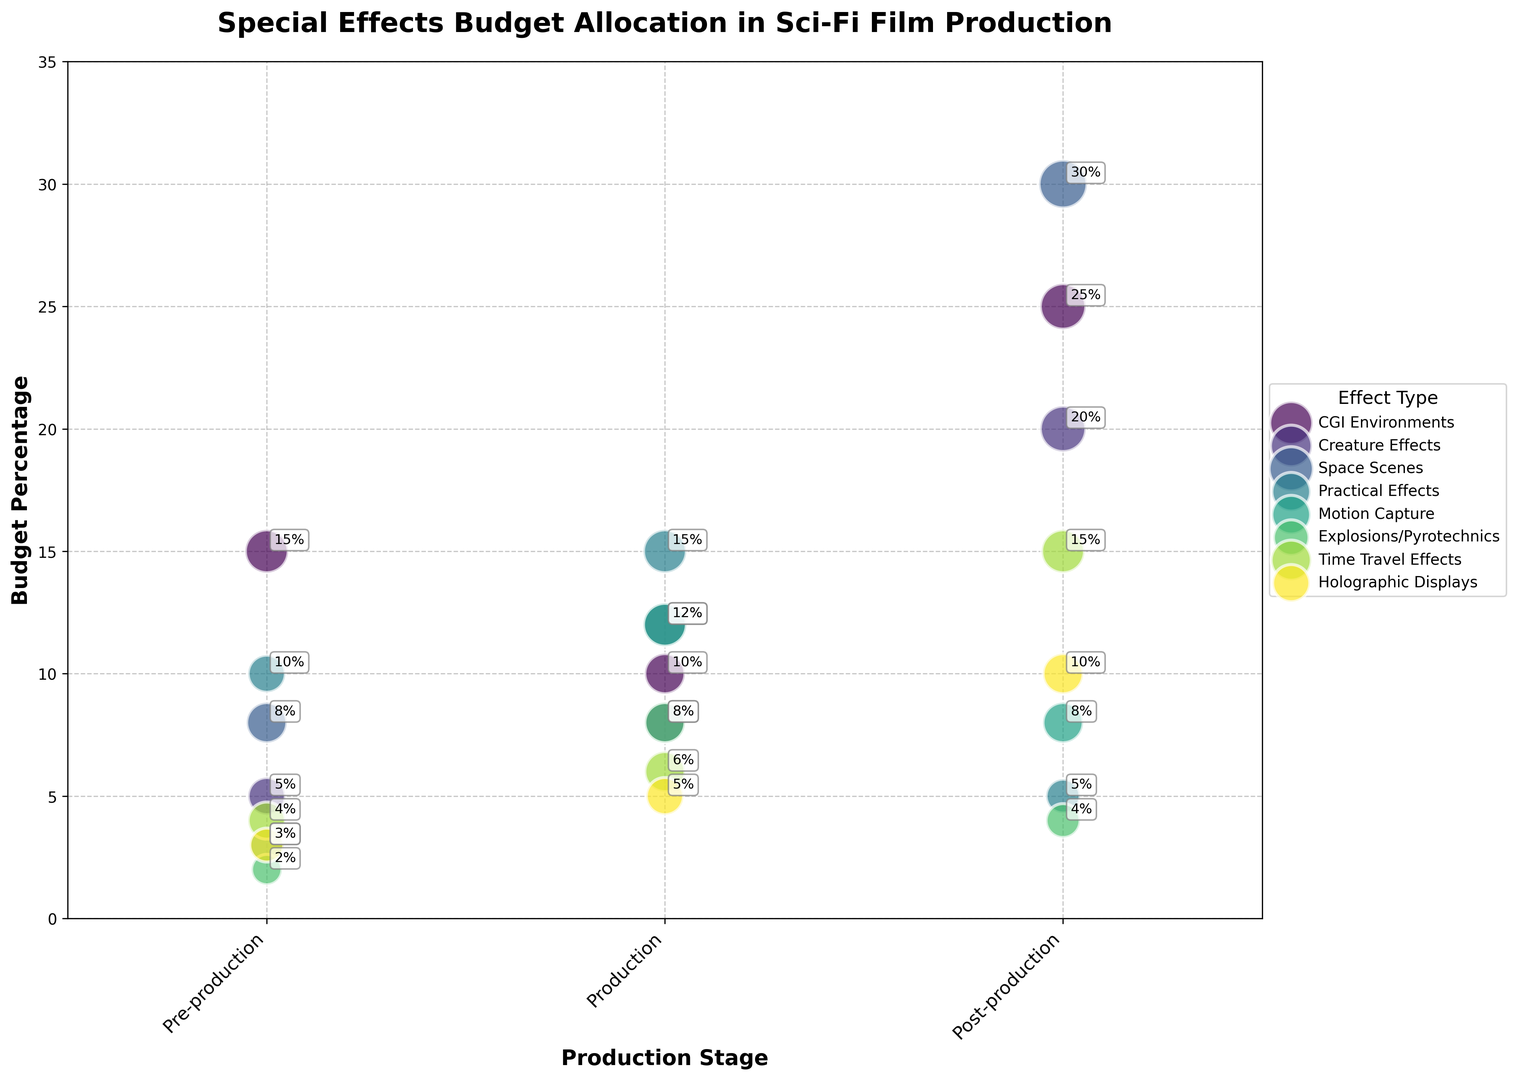What percentage of the budget is allocated to CGI Environments during post-production? Refer to the bubble chart and locate the 'CGI Environments' category at 'Post-production' stage. See the corresponding budget percentage value.
Answer: 25% Which effect type has the largest relative importance size in post-production? Look at the bubbles in the post-production stage, identifying the effect type with the largest bubble size (denoted by relative importance size).
Answer: Space Scenes How does the budget percentage for Practical Effects in production compare to Motion Capture in production? Check the budget percentages for Practical Effects and Motion Capture at the production stage and compare them. Practical Effects is at 15% and Motion Capture at 12%.
Answer: Practical Effects is higher What is the average budget percentage allocated to Creature Effects across all production stages? Sum the budget percentages for Creature Effects in pre-production (5%), production (8%), and post-production (20%) and divide by 3. (5 + 8 + 20) / 3 = 11
Answer: 11% Which production stage has the highest overall budget allocation for Time Travel Effects? Look at the budget percentages for Time Travel Effects across pre-production (4%), production (6%), and post-production (15%).
Answer: Post-production Compare the budget allocation for Space Scenes during production and post-production stages Find the budget percentages for Space Scenes in production and post-production: production is at 12% and post-production is at 30%.
Answer: Post-production is higher What is the sum of budget percentages for Explosions/Pyrotechnics at all production stages? Sum the budget percentages for Explosions/Pyrotechnics: pre-production (2%), production (8%), post-production (4%). 2 + 8 + 4 = 14
Answer: 14% Which effect type has the smallest bubble size (relative importance) in pre-production? Look at the smallest bubbles in the pre-production stage and identify the effect type associated with the smallest size.
Answer: Explosions/Pyrotechnics What is the difference in budget percentage between Pre-production and Post-production for Holographic Displays? Subtract the pre-production budget percentage for Holographic Displays (3%) from the post-production budget percentage (10%). 10 - 3 = 7
Answer: 7% Which production stage shows the highest budget allocation for Motion Capture? Compare the budget percentages for Motion Capture in pre-production (3%), production (12%), and post-production (8%).
Answer: Production 